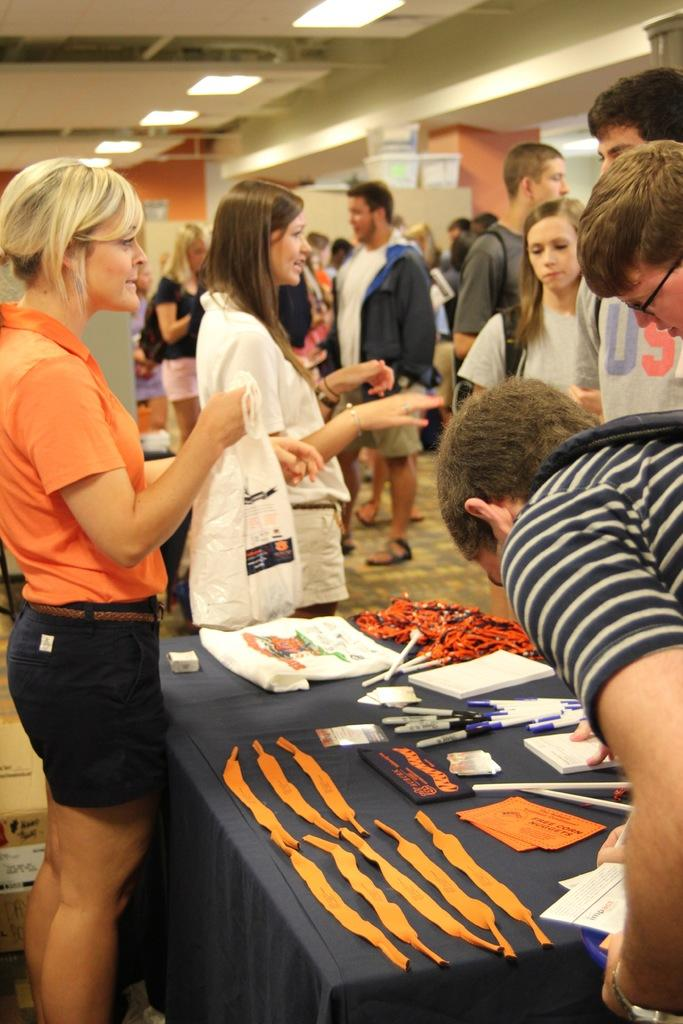What are the people in the image doing? The persons standing on the floor are likely engaged in some activity, but the specifics are not mentioned in the facts. What is on the table in the image? There are pens and books on the table. What can be used for writing in the image? The pens on the table can be used for writing. What is providing illumination in the image? There are lights in the image. What is supporting the ceiling in the image? There is a pillar in the image. What is visible beneath the people's feet? The floor is visible in the image. What statement is being made by the control panel in the image? There is no control panel present in the image, so no statement can be made. What smell is associated with the books in the image? The facts do not mention any smells, so it cannot be determined from the image. 